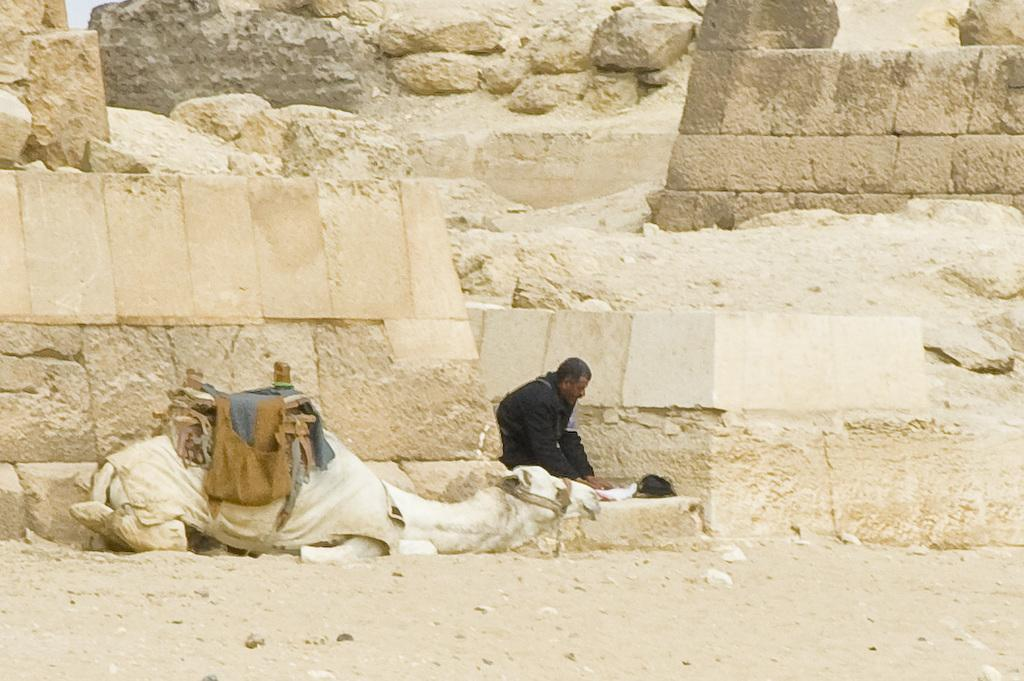What animal is sitting on the sand in the image? There is a camel sitting on the sand in the image. Who is beside the camel in the image? There is a person wearing a black dress beside the camel. What can be seen in the background of the image? There are other objects visible in the background. Is there a birthday celebration happening in the image? There is no indication of a birthday celebration in the image. Can you see any rainstorm in the image? There is no rainstorm visible in the image. 